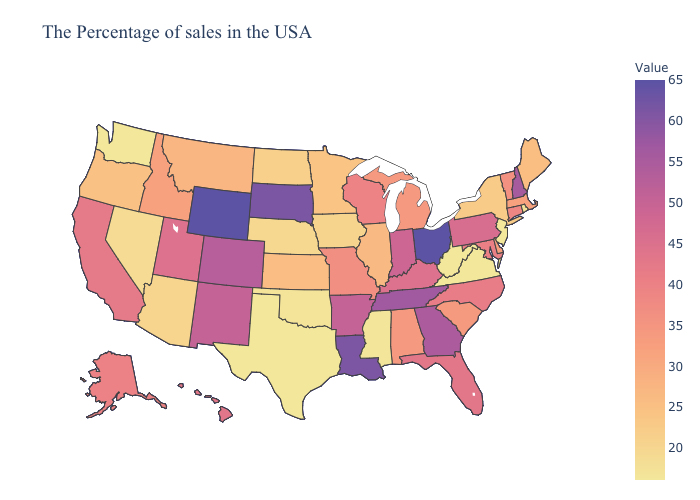Does Wisconsin have a lower value than Arizona?
Concise answer only. No. Which states have the highest value in the USA?
Be succinct. Ohio, Wyoming. Does Texas have the lowest value in the USA?
Answer briefly. Yes. Which states have the highest value in the USA?
Quick response, please. Ohio, Wyoming. 